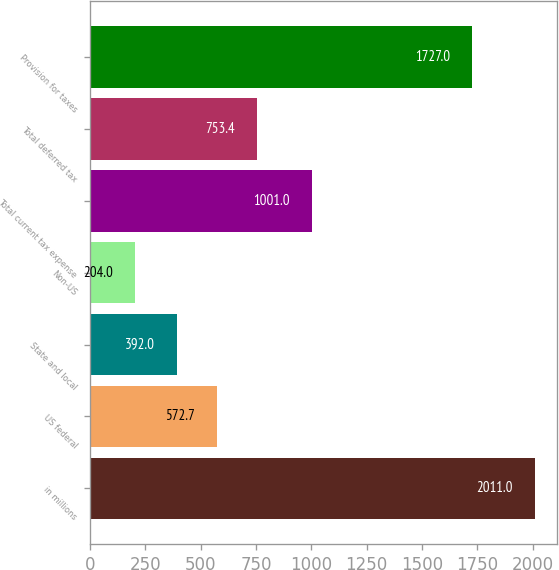Convert chart. <chart><loc_0><loc_0><loc_500><loc_500><bar_chart><fcel>in millions<fcel>US federal<fcel>State and local<fcel>Non-US<fcel>Total current tax expense<fcel>Total deferred tax<fcel>Provision for taxes<nl><fcel>2011<fcel>572.7<fcel>392<fcel>204<fcel>1001<fcel>753.4<fcel>1727<nl></chart> 